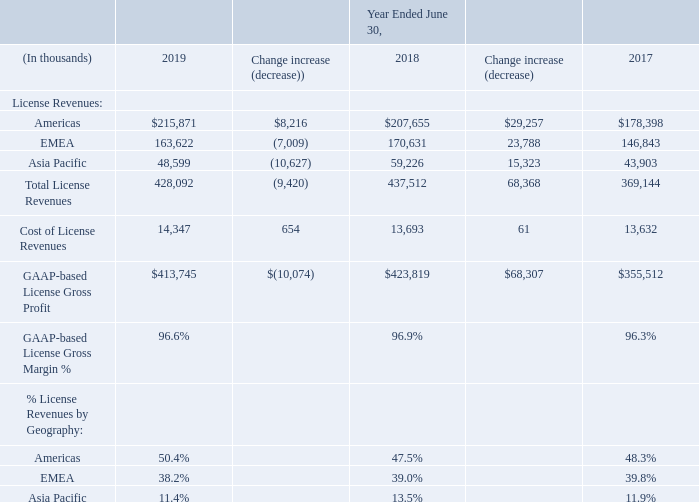Revenues, Cost of Revenues and Gross Margin by Product Type
1) License: Our license revenue can be broadly categorized as perpetual licenses, term licenses and subscription licenses, all of which are deployed on the customer’s premises (on-premise). Our license revenues are impacted by the strength of general economic and industry conditions, the competitive strength of our software products, and our acquisitions. Cost of license revenues consists primarily of royalties payable to third parties.
License revenues decreased by $9.4 million or 2.2% during the year ended June 30, 2019 as compared to the prior fiscal year; up 0.4% after factoring the impact of $11.2 million of foreign exchange rate changes. Geographically, the overall change was attributable to an increase in Americas of $8.2 million, offset by a decrease in Asia Pacific of $10.6 million and a decrease in EMEA of $7.0 million.
During Fiscal 2019, we closed 153 license deals greater than $0.5 million, of which 49 deals were greater than $1.0 million, contributing approximately $144.1 million of license revenues. This was compared to 140 deals greater than $0.5 million during Fiscal 2018, of which 58 deals were greater than $1.0 million, contributing $152.2 million of license revenues.
Cost of license revenues increased by $0.7 million during the year ended June 30, 2019 as compared to the prior fiscal year. The gross margin percentage on license revenues remained at approximately 97%.
For illustrative purposes only, had we accounted for revenues under proforma Topic 605, license revenues would have been $390.4 million for the year ended June 30, 2019, which would have been lower by approximately $47.1 million or 10.8% as compared to the prior fiscal year; and would have been lower by 8.4% after factoring the impact of $10.4 million of foreign exchange rate changes. Geographically, the overall change would have been attributable to a decrease in Americas of $17.7 million, a decrease in EMEA of $15.7 million and a decrease in Asia Pacific of $13.7 million.
The $37.7 million difference between license revenues recognized under Topic 606 and those proforma Topic 605 license revenues described above is the result of timing differences, where under Topic 605, revenues would have been deferred and recognized over time, but under Topic 606 these revenues are recognized up front. For more details, see note 3 "Revenues" to our Consolidated Financial Statements.
How much did Cost of license revenues increase by in the year ended June 30, 2019 as compared to the prior fiscal year? $0.7 million. During Fiscal 2019, how much deals greater than $1.0 million were closed? 49 deals. What was the change increase in License revenues for Americas for 2018 to 2019?
Answer scale should be: thousand. $8,216. What is the percentage decrease of Total License Revenues from 2018 to 2019?
Answer scale should be: percent. 9,420/437,512
Answer: 2.15. For 2019. what is the Cost of License Revenues expressed as a percentage of GAAP-based License Gross Profit? 
Answer scale should be: percent. 14,347/413,745
Answer: 3.47. What is the average annual GAAP-based License Gross Profit for the 3 years?
Answer scale should be: thousand. (413,745+423,819+355,512)/3
Answer: 397692. 